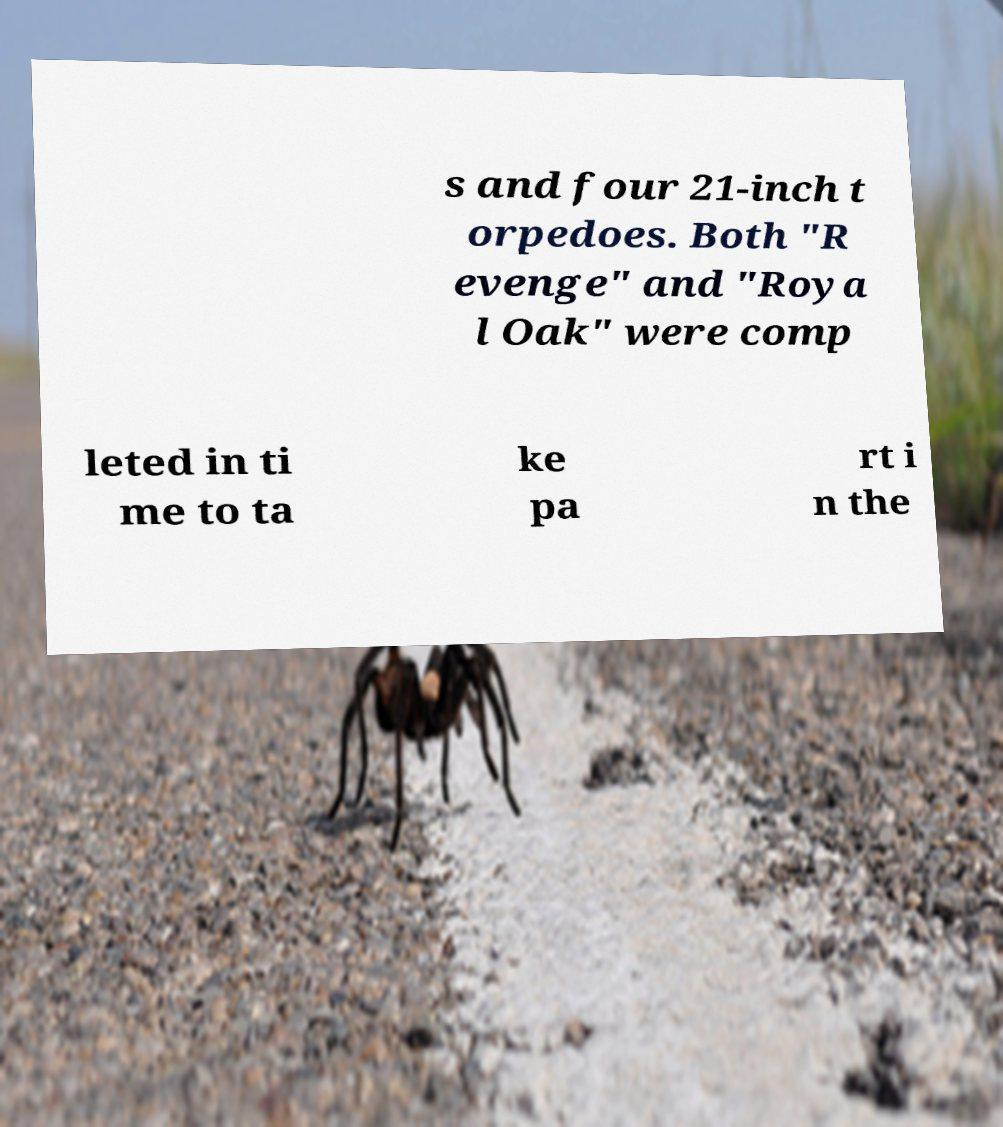Could you assist in decoding the text presented in this image and type it out clearly? s and four 21-inch t orpedoes. Both "R evenge" and "Roya l Oak" were comp leted in ti me to ta ke pa rt i n the 